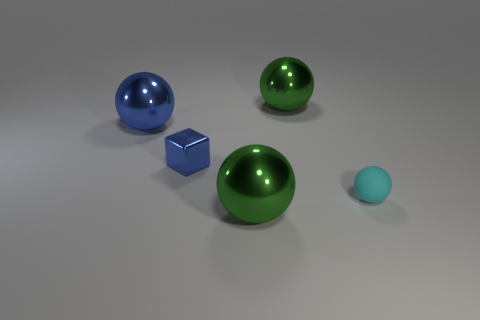There is a tiny cyan thing that is the same shape as the large blue shiny thing; what material is it?
Keep it short and to the point. Rubber. The blue metal sphere is what size?
Make the answer very short. Large. How many other objects are the same color as the small metallic object?
Make the answer very short. 1. Is the small thing on the left side of the matte ball made of the same material as the blue ball?
Make the answer very short. Yes. Is the number of green balls that are in front of the tiny sphere less than the number of big things that are to the left of the small blue block?
Offer a terse response. No. How many other objects are the same material as the tiny ball?
Your response must be concise. 0. What material is the cyan sphere that is the same size as the blue shiny block?
Offer a very short reply. Rubber. Is the number of small blue cubes to the left of the small shiny block less than the number of big blue metal balls?
Ensure brevity in your answer.  Yes. There is a large thing that is left of the green thing that is in front of the shiny ball behind the large blue object; what is its shape?
Your answer should be compact. Sphere. What size is the green thing that is behind the tiny blue metallic cube?
Offer a terse response. Large. 